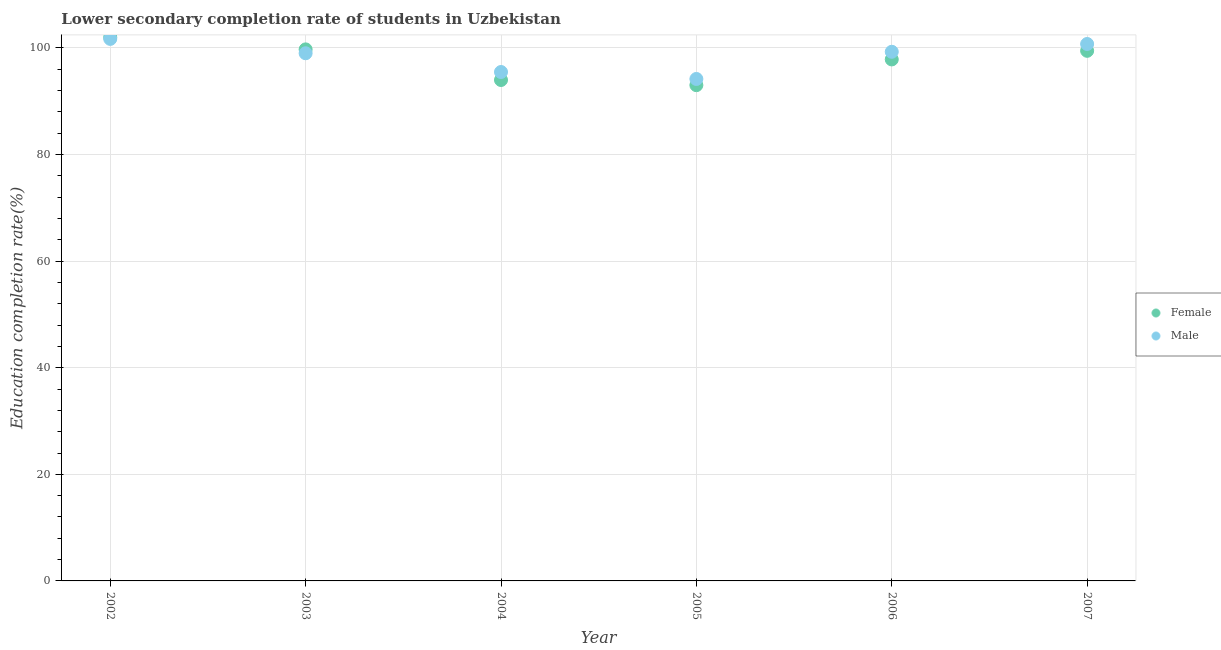How many different coloured dotlines are there?
Offer a terse response. 2. Is the number of dotlines equal to the number of legend labels?
Your answer should be compact. Yes. What is the education completion rate of female students in 2004?
Keep it short and to the point. 93.98. Across all years, what is the maximum education completion rate of female students?
Give a very brief answer. 102. Across all years, what is the minimum education completion rate of male students?
Give a very brief answer. 94.18. In which year was the education completion rate of male students maximum?
Provide a succinct answer. 2002. In which year was the education completion rate of male students minimum?
Give a very brief answer. 2005. What is the total education completion rate of male students in the graph?
Keep it short and to the point. 590.36. What is the difference between the education completion rate of male students in 2003 and that in 2005?
Make the answer very short. 4.82. What is the difference between the education completion rate of male students in 2007 and the education completion rate of female students in 2002?
Offer a terse response. -1.26. What is the average education completion rate of male students per year?
Your response must be concise. 98.39. In the year 2003, what is the difference between the education completion rate of male students and education completion rate of female students?
Ensure brevity in your answer.  -0.73. In how many years, is the education completion rate of female students greater than 12 %?
Make the answer very short. 6. What is the ratio of the education completion rate of female students in 2003 to that in 2004?
Your response must be concise. 1.06. Is the education completion rate of male students in 2002 less than that in 2004?
Keep it short and to the point. No. Is the difference between the education completion rate of male students in 2004 and 2007 greater than the difference between the education completion rate of female students in 2004 and 2007?
Offer a terse response. Yes. What is the difference between the highest and the second highest education completion rate of male students?
Your response must be concise. 0.95. What is the difference between the highest and the lowest education completion rate of female students?
Your response must be concise. 8.98. In how many years, is the education completion rate of female students greater than the average education completion rate of female students taken over all years?
Offer a terse response. 4. Is the education completion rate of female students strictly greater than the education completion rate of male students over the years?
Give a very brief answer. No. Is the education completion rate of female students strictly less than the education completion rate of male students over the years?
Ensure brevity in your answer.  No. How many dotlines are there?
Provide a short and direct response. 2. Does the graph contain any zero values?
Make the answer very short. No. How many legend labels are there?
Offer a terse response. 2. How are the legend labels stacked?
Give a very brief answer. Vertical. What is the title of the graph?
Your answer should be compact. Lower secondary completion rate of students in Uzbekistan. What is the label or title of the Y-axis?
Your response must be concise. Education completion rate(%). What is the Education completion rate(%) of Female in 2002?
Keep it short and to the point. 102. What is the Education completion rate(%) in Male in 2002?
Make the answer very short. 101.69. What is the Education completion rate(%) in Female in 2003?
Make the answer very short. 99.72. What is the Education completion rate(%) in Male in 2003?
Provide a short and direct response. 99. What is the Education completion rate(%) in Female in 2004?
Provide a succinct answer. 93.98. What is the Education completion rate(%) in Male in 2004?
Ensure brevity in your answer.  95.48. What is the Education completion rate(%) in Female in 2005?
Provide a short and direct response. 93.01. What is the Education completion rate(%) of Male in 2005?
Keep it short and to the point. 94.18. What is the Education completion rate(%) of Female in 2006?
Offer a terse response. 97.84. What is the Education completion rate(%) of Male in 2006?
Your response must be concise. 99.27. What is the Education completion rate(%) in Female in 2007?
Your answer should be very brief. 99.46. What is the Education completion rate(%) of Male in 2007?
Your answer should be very brief. 100.74. Across all years, what is the maximum Education completion rate(%) in Female?
Provide a short and direct response. 102. Across all years, what is the maximum Education completion rate(%) in Male?
Provide a short and direct response. 101.69. Across all years, what is the minimum Education completion rate(%) in Female?
Make the answer very short. 93.01. Across all years, what is the minimum Education completion rate(%) of Male?
Your response must be concise. 94.18. What is the total Education completion rate(%) in Female in the graph?
Provide a short and direct response. 586.01. What is the total Education completion rate(%) of Male in the graph?
Your answer should be very brief. 590.36. What is the difference between the Education completion rate(%) in Female in 2002 and that in 2003?
Ensure brevity in your answer.  2.27. What is the difference between the Education completion rate(%) in Male in 2002 and that in 2003?
Your response must be concise. 2.69. What is the difference between the Education completion rate(%) of Female in 2002 and that in 2004?
Give a very brief answer. 8.02. What is the difference between the Education completion rate(%) of Male in 2002 and that in 2004?
Provide a succinct answer. 6.21. What is the difference between the Education completion rate(%) in Female in 2002 and that in 2005?
Your answer should be compact. 8.98. What is the difference between the Education completion rate(%) in Male in 2002 and that in 2005?
Keep it short and to the point. 7.52. What is the difference between the Education completion rate(%) in Female in 2002 and that in 2006?
Make the answer very short. 4.16. What is the difference between the Education completion rate(%) in Male in 2002 and that in 2006?
Your answer should be very brief. 2.42. What is the difference between the Education completion rate(%) of Female in 2002 and that in 2007?
Ensure brevity in your answer.  2.54. What is the difference between the Education completion rate(%) in Male in 2002 and that in 2007?
Offer a terse response. 0.95. What is the difference between the Education completion rate(%) of Female in 2003 and that in 2004?
Offer a very short reply. 5.74. What is the difference between the Education completion rate(%) of Male in 2003 and that in 2004?
Your response must be concise. 3.52. What is the difference between the Education completion rate(%) of Female in 2003 and that in 2005?
Offer a very short reply. 6.71. What is the difference between the Education completion rate(%) of Male in 2003 and that in 2005?
Keep it short and to the point. 4.82. What is the difference between the Education completion rate(%) in Female in 2003 and that in 2006?
Offer a terse response. 1.88. What is the difference between the Education completion rate(%) in Male in 2003 and that in 2006?
Your answer should be compact. -0.28. What is the difference between the Education completion rate(%) of Female in 2003 and that in 2007?
Offer a very short reply. 0.27. What is the difference between the Education completion rate(%) of Male in 2003 and that in 2007?
Offer a very short reply. -1.74. What is the difference between the Education completion rate(%) of Female in 2004 and that in 2005?
Your answer should be compact. 0.97. What is the difference between the Education completion rate(%) in Male in 2004 and that in 2005?
Give a very brief answer. 1.3. What is the difference between the Education completion rate(%) of Female in 2004 and that in 2006?
Give a very brief answer. -3.86. What is the difference between the Education completion rate(%) in Male in 2004 and that in 2006?
Keep it short and to the point. -3.79. What is the difference between the Education completion rate(%) in Female in 2004 and that in 2007?
Your answer should be compact. -5.48. What is the difference between the Education completion rate(%) in Male in 2004 and that in 2007?
Provide a succinct answer. -5.26. What is the difference between the Education completion rate(%) in Female in 2005 and that in 2006?
Your answer should be compact. -4.83. What is the difference between the Education completion rate(%) in Male in 2005 and that in 2006?
Your response must be concise. -5.1. What is the difference between the Education completion rate(%) in Female in 2005 and that in 2007?
Give a very brief answer. -6.44. What is the difference between the Education completion rate(%) of Male in 2005 and that in 2007?
Provide a succinct answer. -6.56. What is the difference between the Education completion rate(%) of Female in 2006 and that in 2007?
Offer a terse response. -1.62. What is the difference between the Education completion rate(%) in Male in 2006 and that in 2007?
Keep it short and to the point. -1.46. What is the difference between the Education completion rate(%) in Female in 2002 and the Education completion rate(%) in Male in 2003?
Give a very brief answer. 3. What is the difference between the Education completion rate(%) of Female in 2002 and the Education completion rate(%) of Male in 2004?
Your response must be concise. 6.52. What is the difference between the Education completion rate(%) in Female in 2002 and the Education completion rate(%) in Male in 2005?
Keep it short and to the point. 7.82. What is the difference between the Education completion rate(%) of Female in 2002 and the Education completion rate(%) of Male in 2006?
Provide a succinct answer. 2.72. What is the difference between the Education completion rate(%) of Female in 2002 and the Education completion rate(%) of Male in 2007?
Your answer should be very brief. 1.26. What is the difference between the Education completion rate(%) of Female in 2003 and the Education completion rate(%) of Male in 2004?
Keep it short and to the point. 4.24. What is the difference between the Education completion rate(%) in Female in 2003 and the Education completion rate(%) in Male in 2005?
Provide a succinct answer. 5.55. What is the difference between the Education completion rate(%) in Female in 2003 and the Education completion rate(%) in Male in 2006?
Provide a short and direct response. 0.45. What is the difference between the Education completion rate(%) of Female in 2003 and the Education completion rate(%) of Male in 2007?
Make the answer very short. -1.01. What is the difference between the Education completion rate(%) in Female in 2004 and the Education completion rate(%) in Male in 2005?
Keep it short and to the point. -0.2. What is the difference between the Education completion rate(%) in Female in 2004 and the Education completion rate(%) in Male in 2006?
Make the answer very short. -5.3. What is the difference between the Education completion rate(%) in Female in 2004 and the Education completion rate(%) in Male in 2007?
Your answer should be compact. -6.76. What is the difference between the Education completion rate(%) of Female in 2005 and the Education completion rate(%) of Male in 2006?
Your answer should be compact. -6.26. What is the difference between the Education completion rate(%) in Female in 2005 and the Education completion rate(%) in Male in 2007?
Keep it short and to the point. -7.72. What is the difference between the Education completion rate(%) of Female in 2006 and the Education completion rate(%) of Male in 2007?
Give a very brief answer. -2.9. What is the average Education completion rate(%) of Female per year?
Your answer should be compact. 97.67. What is the average Education completion rate(%) in Male per year?
Your answer should be compact. 98.39. In the year 2002, what is the difference between the Education completion rate(%) in Female and Education completion rate(%) in Male?
Make the answer very short. 0.31. In the year 2003, what is the difference between the Education completion rate(%) of Female and Education completion rate(%) of Male?
Keep it short and to the point. 0.73. In the year 2004, what is the difference between the Education completion rate(%) in Female and Education completion rate(%) in Male?
Keep it short and to the point. -1.5. In the year 2005, what is the difference between the Education completion rate(%) in Female and Education completion rate(%) in Male?
Keep it short and to the point. -1.16. In the year 2006, what is the difference between the Education completion rate(%) of Female and Education completion rate(%) of Male?
Offer a terse response. -1.43. In the year 2007, what is the difference between the Education completion rate(%) in Female and Education completion rate(%) in Male?
Make the answer very short. -1.28. What is the ratio of the Education completion rate(%) of Female in 2002 to that in 2003?
Your response must be concise. 1.02. What is the ratio of the Education completion rate(%) of Male in 2002 to that in 2003?
Your answer should be compact. 1.03. What is the ratio of the Education completion rate(%) in Female in 2002 to that in 2004?
Your answer should be compact. 1.09. What is the ratio of the Education completion rate(%) in Male in 2002 to that in 2004?
Provide a succinct answer. 1.07. What is the ratio of the Education completion rate(%) of Female in 2002 to that in 2005?
Keep it short and to the point. 1.1. What is the ratio of the Education completion rate(%) of Male in 2002 to that in 2005?
Offer a very short reply. 1.08. What is the ratio of the Education completion rate(%) of Female in 2002 to that in 2006?
Provide a short and direct response. 1.04. What is the ratio of the Education completion rate(%) of Male in 2002 to that in 2006?
Your response must be concise. 1.02. What is the ratio of the Education completion rate(%) of Female in 2002 to that in 2007?
Your answer should be very brief. 1.03. What is the ratio of the Education completion rate(%) in Male in 2002 to that in 2007?
Your response must be concise. 1.01. What is the ratio of the Education completion rate(%) of Female in 2003 to that in 2004?
Offer a terse response. 1.06. What is the ratio of the Education completion rate(%) in Male in 2003 to that in 2004?
Offer a very short reply. 1.04. What is the ratio of the Education completion rate(%) of Female in 2003 to that in 2005?
Ensure brevity in your answer.  1.07. What is the ratio of the Education completion rate(%) of Male in 2003 to that in 2005?
Offer a very short reply. 1.05. What is the ratio of the Education completion rate(%) in Female in 2003 to that in 2006?
Keep it short and to the point. 1.02. What is the ratio of the Education completion rate(%) in Male in 2003 to that in 2007?
Your answer should be compact. 0.98. What is the ratio of the Education completion rate(%) in Female in 2004 to that in 2005?
Ensure brevity in your answer.  1.01. What is the ratio of the Education completion rate(%) of Male in 2004 to that in 2005?
Keep it short and to the point. 1.01. What is the ratio of the Education completion rate(%) of Female in 2004 to that in 2006?
Provide a short and direct response. 0.96. What is the ratio of the Education completion rate(%) in Male in 2004 to that in 2006?
Provide a succinct answer. 0.96. What is the ratio of the Education completion rate(%) in Female in 2004 to that in 2007?
Your answer should be very brief. 0.94. What is the ratio of the Education completion rate(%) in Male in 2004 to that in 2007?
Offer a very short reply. 0.95. What is the ratio of the Education completion rate(%) in Female in 2005 to that in 2006?
Your response must be concise. 0.95. What is the ratio of the Education completion rate(%) of Male in 2005 to that in 2006?
Your answer should be compact. 0.95. What is the ratio of the Education completion rate(%) in Female in 2005 to that in 2007?
Offer a very short reply. 0.94. What is the ratio of the Education completion rate(%) of Male in 2005 to that in 2007?
Make the answer very short. 0.93. What is the ratio of the Education completion rate(%) in Female in 2006 to that in 2007?
Your answer should be very brief. 0.98. What is the ratio of the Education completion rate(%) of Male in 2006 to that in 2007?
Make the answer very short. 0.99. What is the difference between the highest and the second highest Education completion rate(%) in Female?
Offer a very short reply. 2.27. What is the difference between the highest and the second highest Education completion rate(%) in Male?
Make the answer very short. 0.95. What is the difference between the highest and the lowest Education completion rate(%) in Female?
Ensure brevity in your answer.  8.98. What is the difference between the highest and the lowest Education completion rate(%) of Male?
Offer a very short reply. 7.52. 